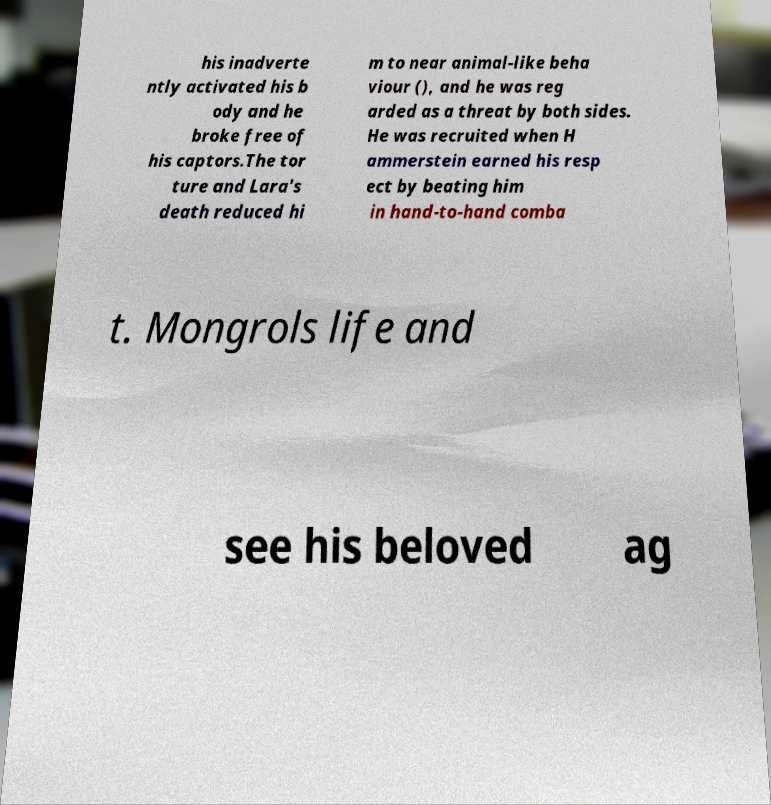Could you assist in decoding the text presented in this image and type it out clearly? his inadverte ntly activated his b ody and he broke free of his captors.The tor ture and Lara's death reduced hi m to near animal-like beha viour (), and he was reg arded as a threat by both sides. He was recruited when H ammerstein earned his resp ect by beating him in hand-to-hand comba t. Mongrols life and see his beloved ag 